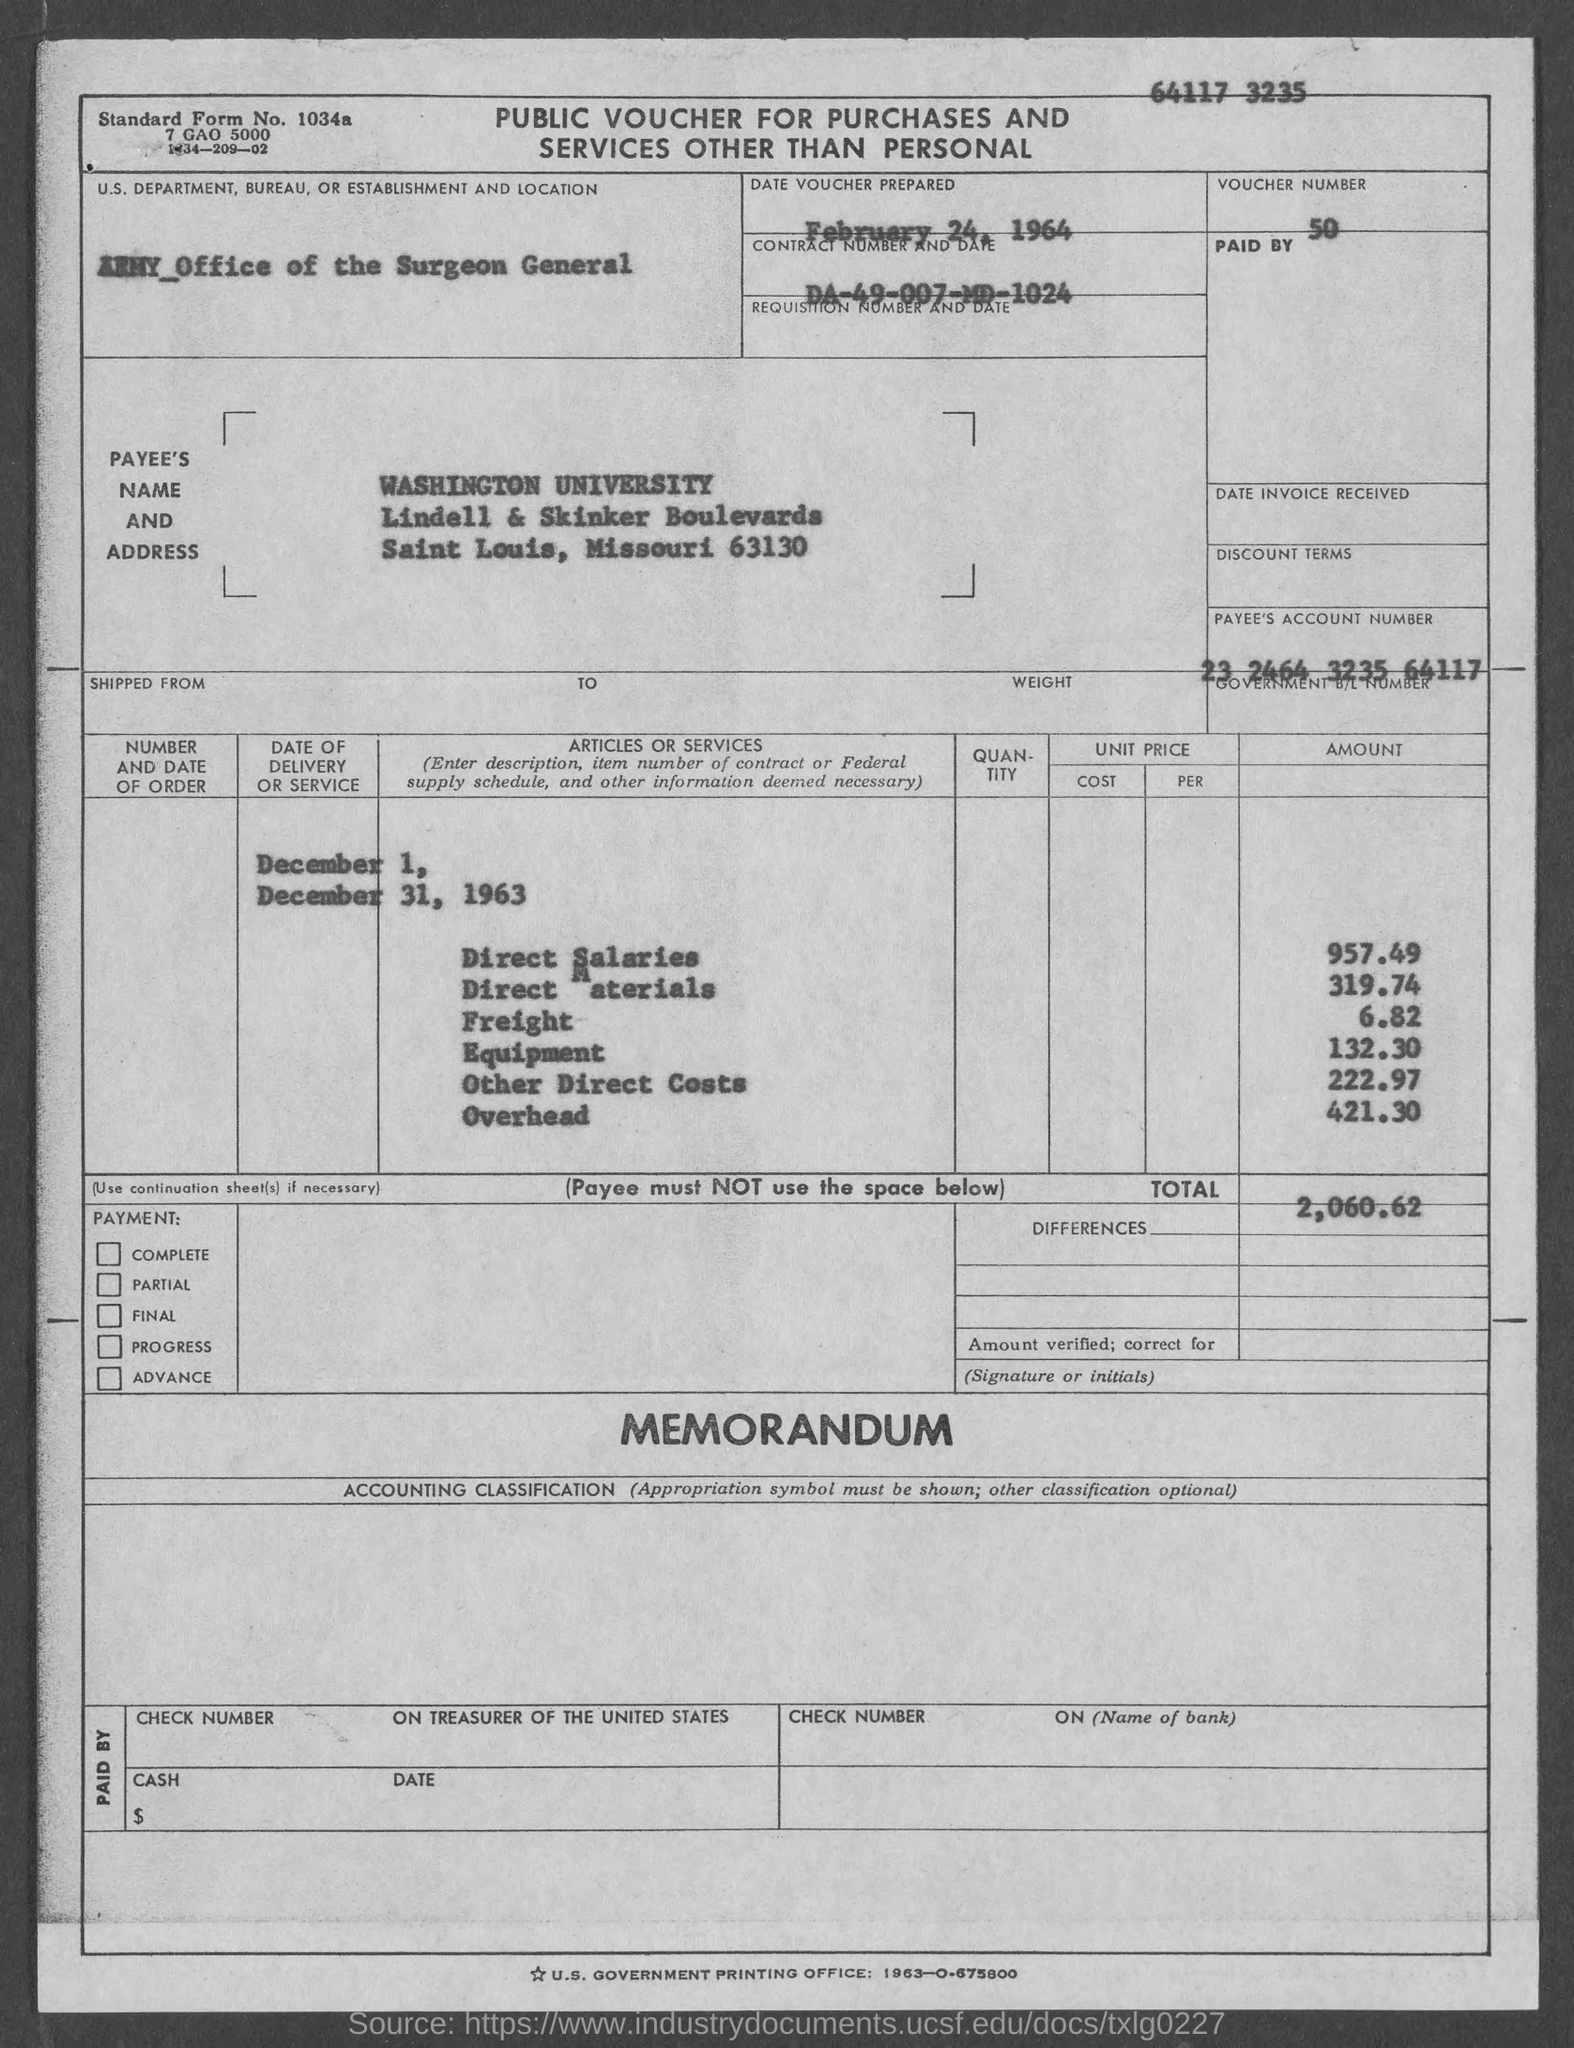What type of voucher is given here?
Your answer should be compact. Public voucher for purchases and services other than personal. What is the Standard Form No. given in the voucher?
Give a very brief answer. 1034a. What is the U.S. Department, Bureau, or Establishment given in the voucher?
Make the answer very short. ARMY_Office of the Surgeon General. What is the voucher number given in the document?
Your answer should be compact. 50. What is the Payee's Account No. given in the voucher?
Your answer should be very brief. 23 2464 3235 64117. What is the date of voucher prepared?
Your answer should be very brief. FEBRUARY 24, 1964. What is the Contract No. given in the voucher?
Provide a succinct answer. DA-49-007-MD-1024. What is the Payee name given in the voucher?
Provide a short and direct response. WASHINGTON UNIVERSITY. What is the direct salaries cost mentioned in the voucher?
Ensure brevity in your answer.  957.49. What is the total amount mentioned in the voucher?
Keep it short and to the point. 2,060.62. 